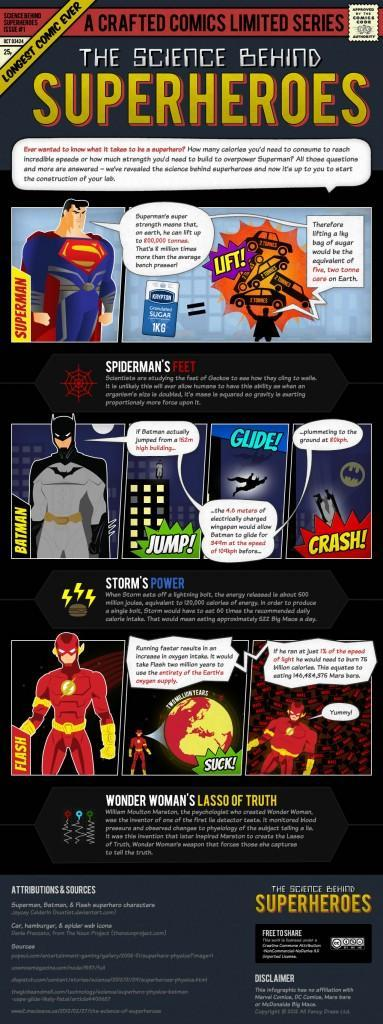How many superheroes are in this infographic?
Answer the question with a short phrase. 3 